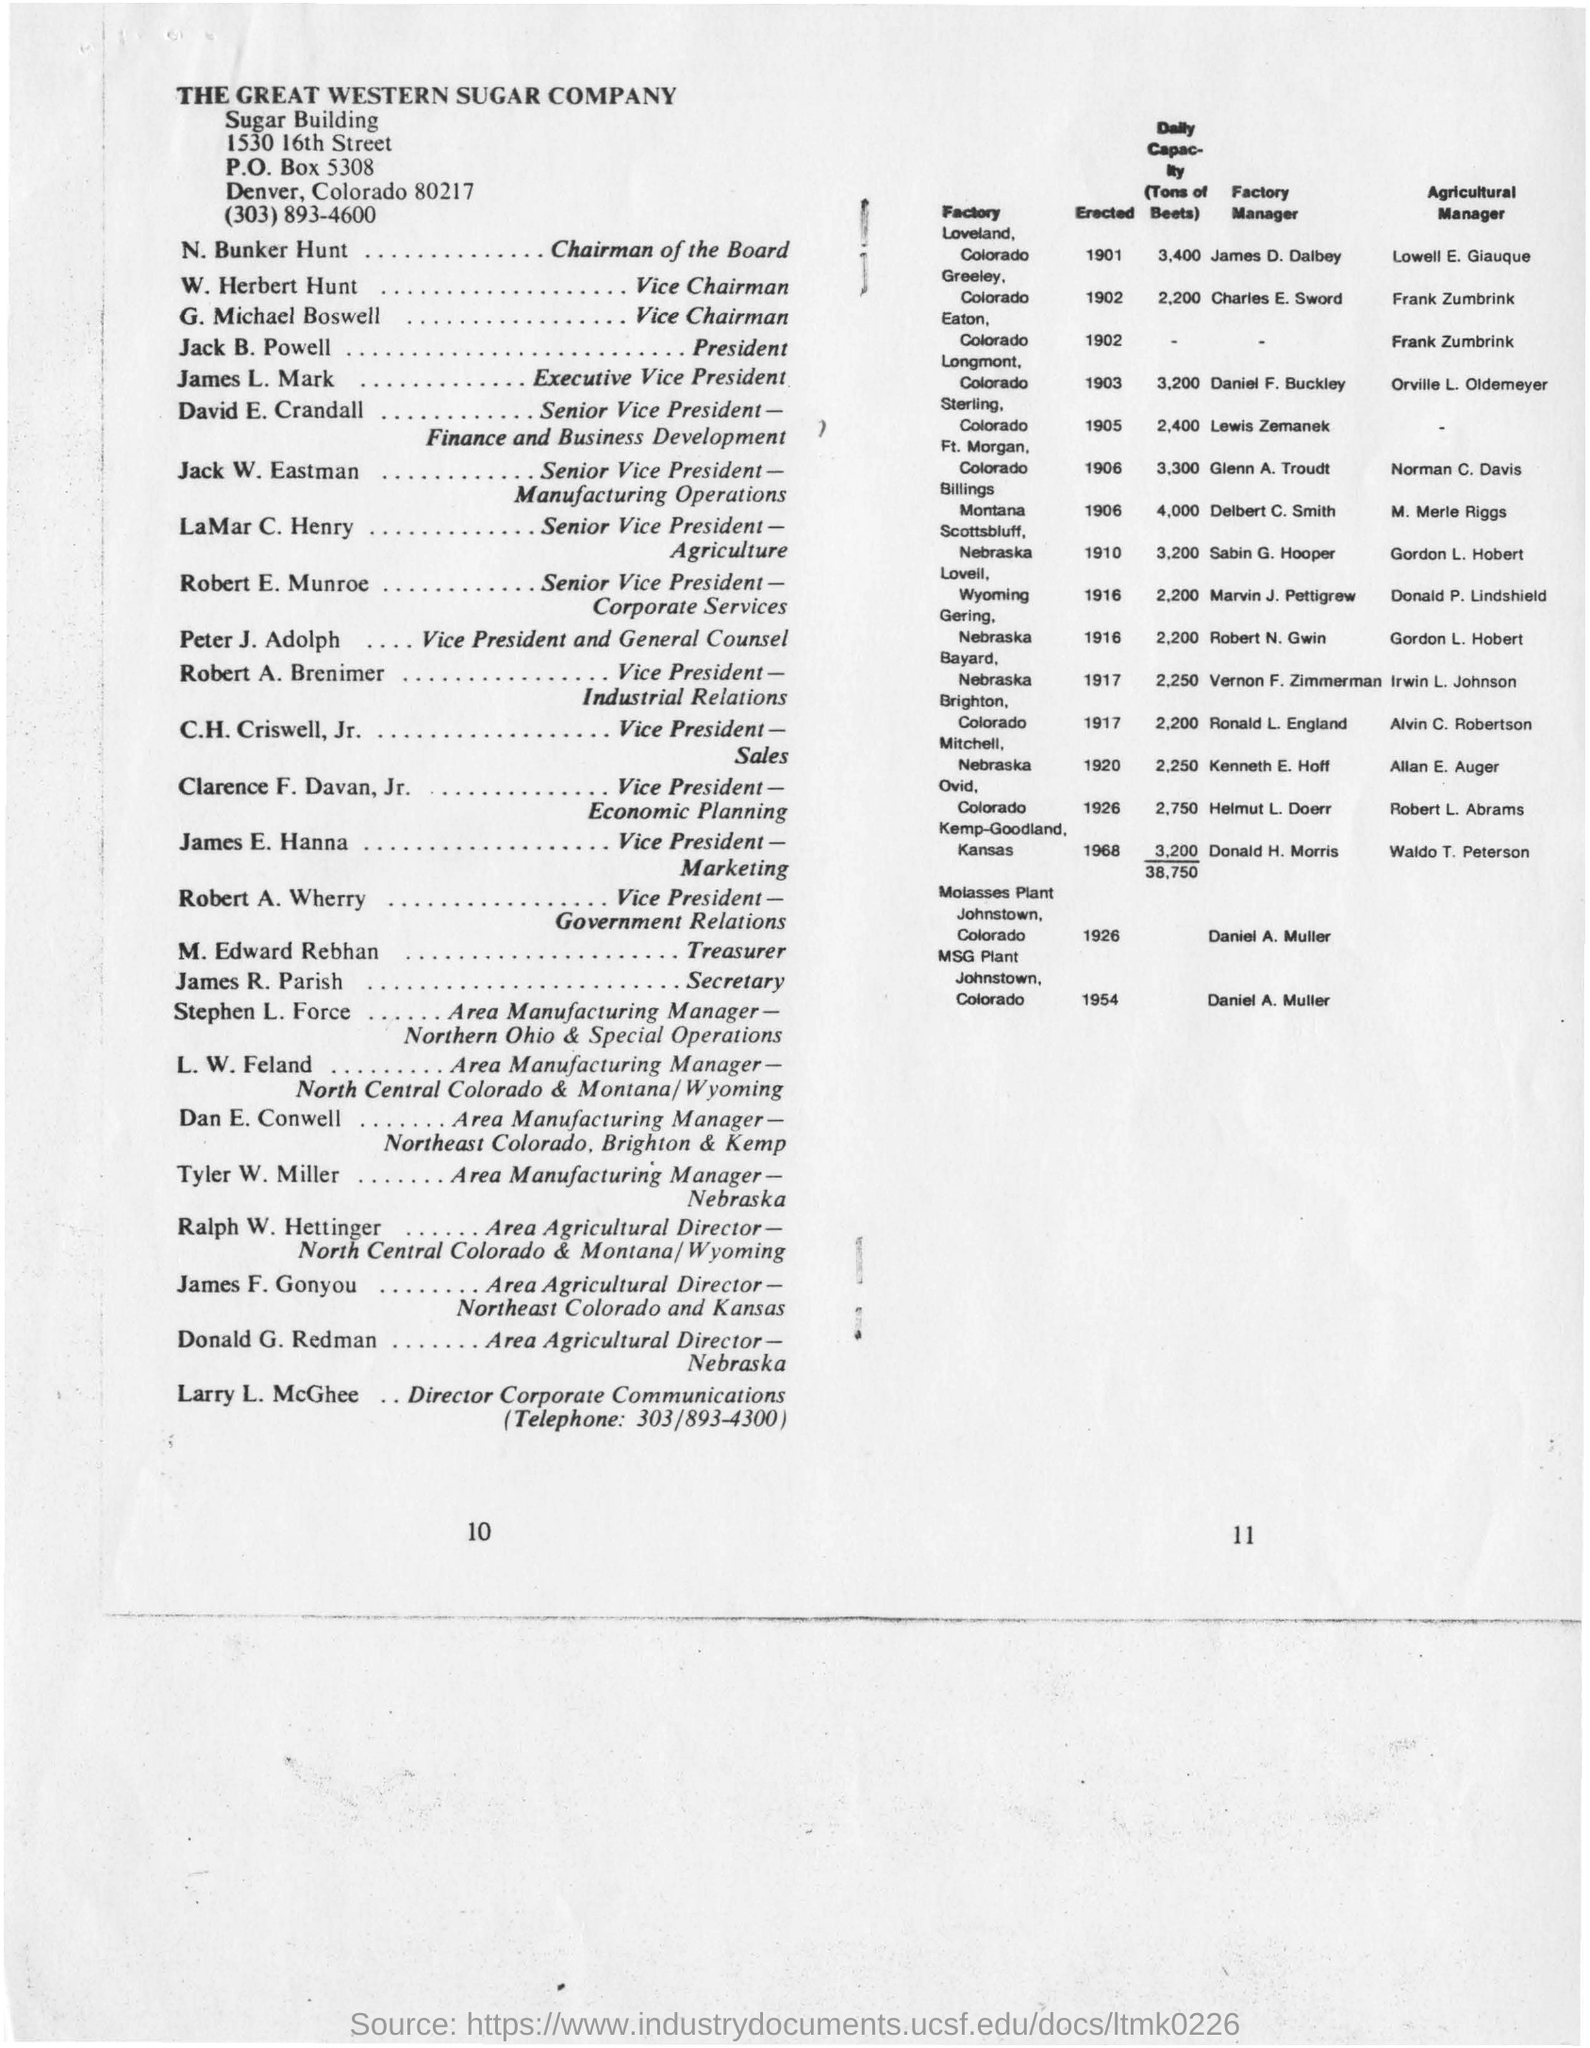Point out several critical features in this image. The Great Western Sugar Company is located in Denver, Colorado, at 80217. The Chairman of the Board is N. Bunker Hunt. M. Edward Rebhan's designation is Treasurer. The daily capacity of the Sterling Factory is 2400 tons of beets. 